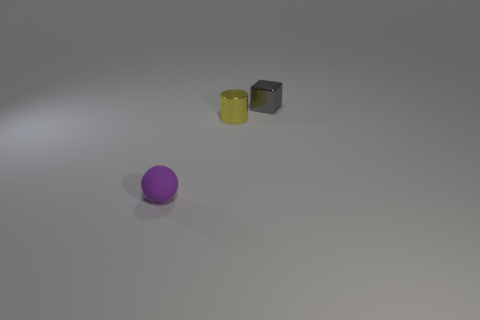The tiny thing on the left side of the small metallic cylinder has what shape?
Your response must be concise. Sphere. There is a metallic thing that is in front of the object right of the metallic object that is left of the gray cube; how big is it?
Your answer should be compact. Small. There is a thing that is in front of the gray metallic thing and behind the tiny purple rubber thing; what is its size?
Make the answer very short. Small. What material is the object on the right side of the small metallic object that is left of the metallic block made of?
Your response must be concise. Metal. What number of rubber things are big yellow things or tiny gray cubes?
Your response must be concise. 0. What color is the small object that is in front of the small metallic object that is on the left side of the tiny object that is to the right of the small yellow metal cylinder?
Your answer should be very brief. Purple. What number of other objects are there of the same material as the small block?
Provide a short and direct response. 1. What number of big things are yellow metallic things or yellow cubes?
Your answer should be compact. 0. Are there an equal number of blocks that are left of the small block and metal things that are behind the sphere?
Your answer should be very brief. No. How many other objects are the same color as the metallic cube?
Offer a very short reply. 0. 